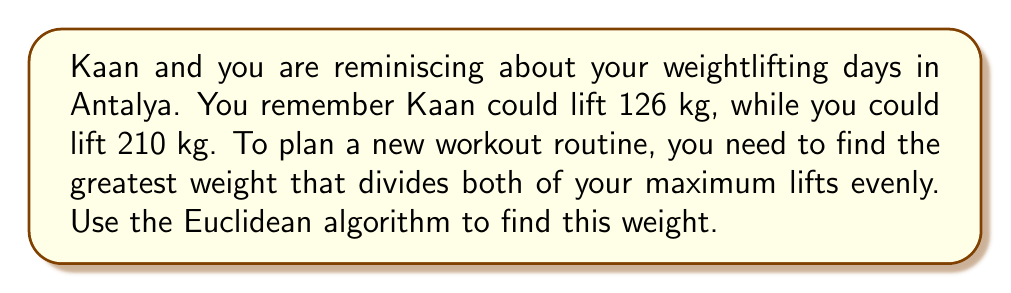Can you answer this question? Let's apply the Euclidean algorithm to find the greatest common divisor (GCD) of 126 and 210.

Step 1: Set up the initial equation
$210 = 1 \times 126 + 84$

Step 2: Use the remainder (84) as the new divisor
$126 = 1 \times 84 + 42$

Step 3: Continue the process
$84 = 2 \times 42 + 0$

The process stops when we get a remainder of 0. The last non-zero remainder is the GCD.

Therefore, $GCD(126, 210) = 42$

We can verify this:
$126 = 3 \times 42$
$210 = 5 \times 42$

Thus, 42 kg is the greatest weight that divides both of your maximum lifts evenly.
Answer: 42 kg 